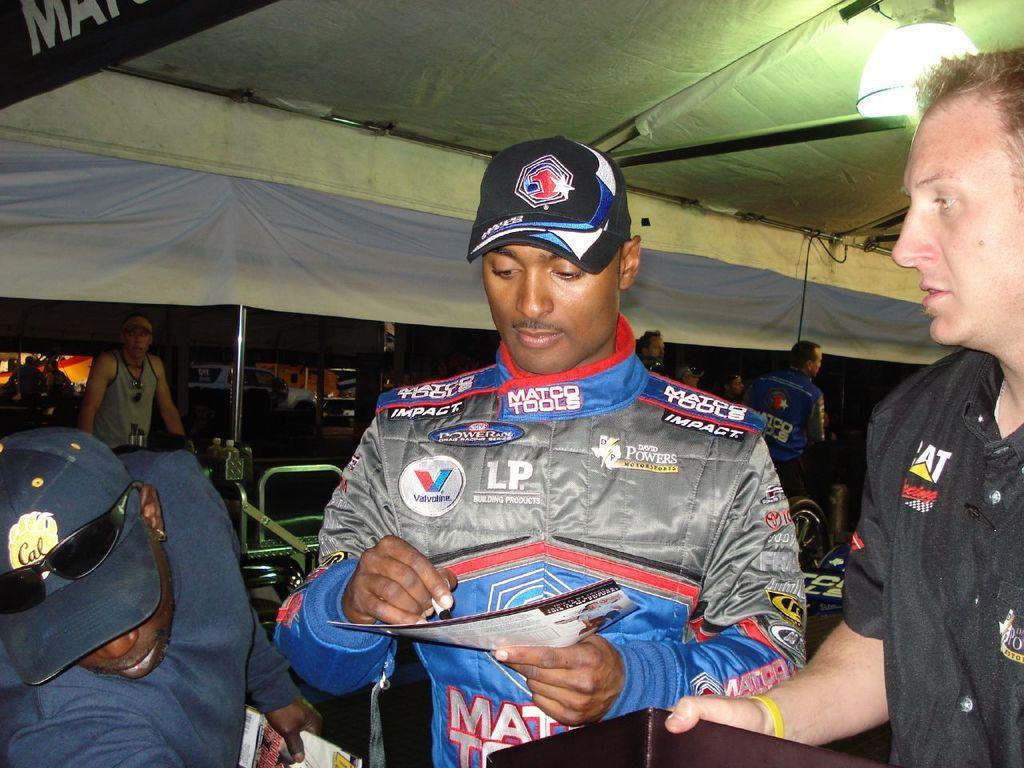Can you describe this image briefly? In this image we can see a few people, two of them are holding papers, one person is holding a pen, there is a light, railing, there is a vehicle, and a tent, also we can see some text on the tent. 